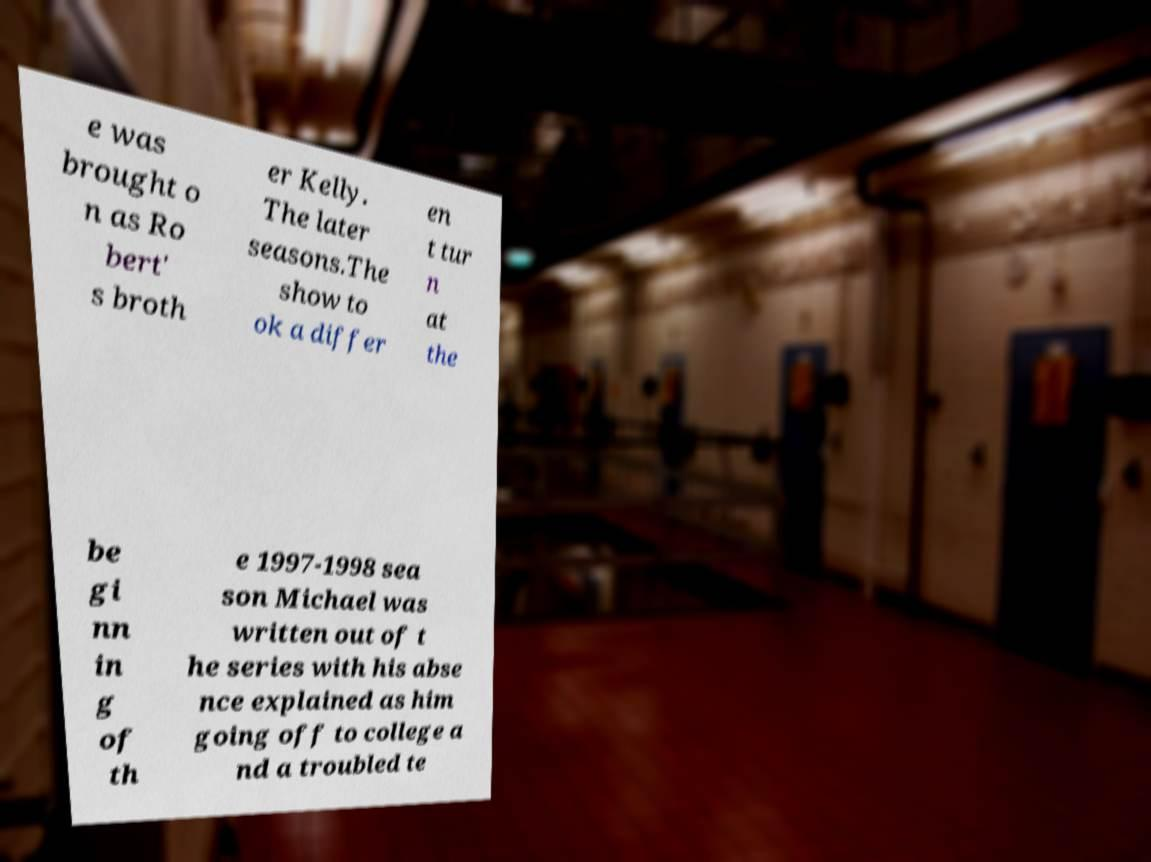Please identify and transcribe the text found in this image. e was brought o n as Ro bert' s broth er Kelly. The later seasons.The show to ok a differ en t tur n at the be gi nn in g of th e 1997-1998 sea son Michael was written out of t he series with his abse nce explained as him going off to college a nd a troubled te 